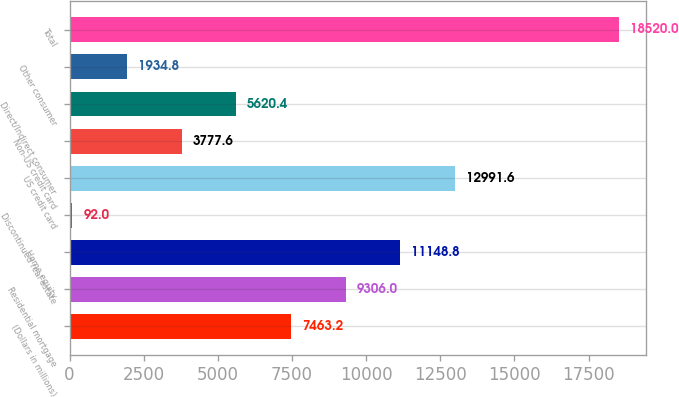Convert chart to OTSL. <chart><loc_0><loc_0><loc_500><loc_500><bar_chart><fcel>(Dollars in millions)<fcel>Residential mortgage<fcel>Home equity<fcel>Discontinued real estate<fcel>US credit card<fcel>Non-US credit card<fcel>Direct/Indirect consumer<fcel>Other consumer<fcel>Total<nl><fcel>7463.2<fcel>9306<fcel>11148.8<fcel>92<fcel>12991.6<fcel>3777.6<fcel>5620.4<fcel>1934.8<fcel>18520<nl></chart> 